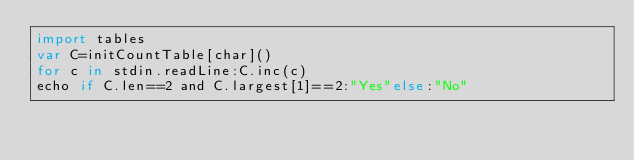Convert code to text. <code><loc_0><loc_0><loc_500><loc_500><_Nim_>import tables
var C=initCountTable[char]()
for c in stdin.readLine:C.inc(c)
echo if C.len==2 and C.largest[1]==2:"Yes"else:"No"</code> 